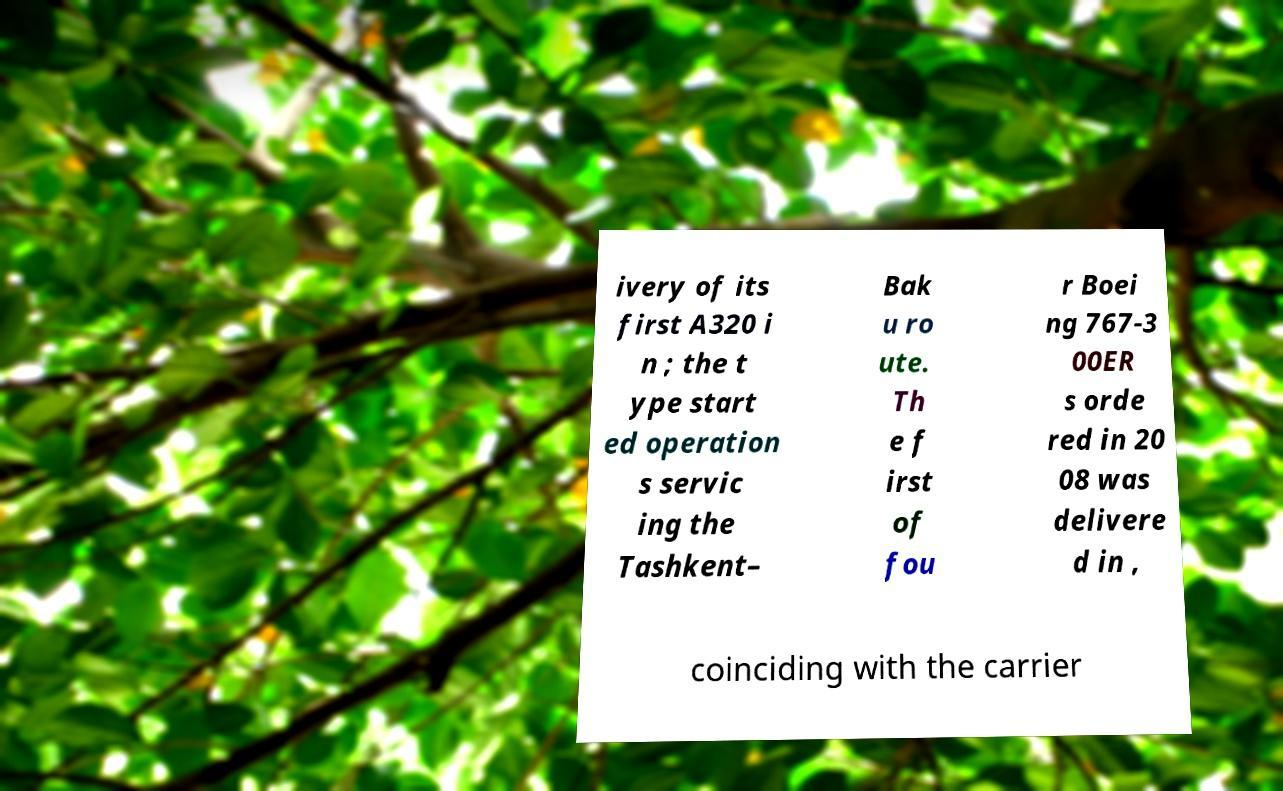For documentation purposes, I need the text within this image transcribed. Could you provide that? ivery of its first A320 i n ; the t ype start ed operation s servic ing the Tashkent– Bak u ro ute. Th e f irst of fou r Boei ng 767-3 00ER s orde red in 20 08 was delivere d in , coinciding with the carrier 